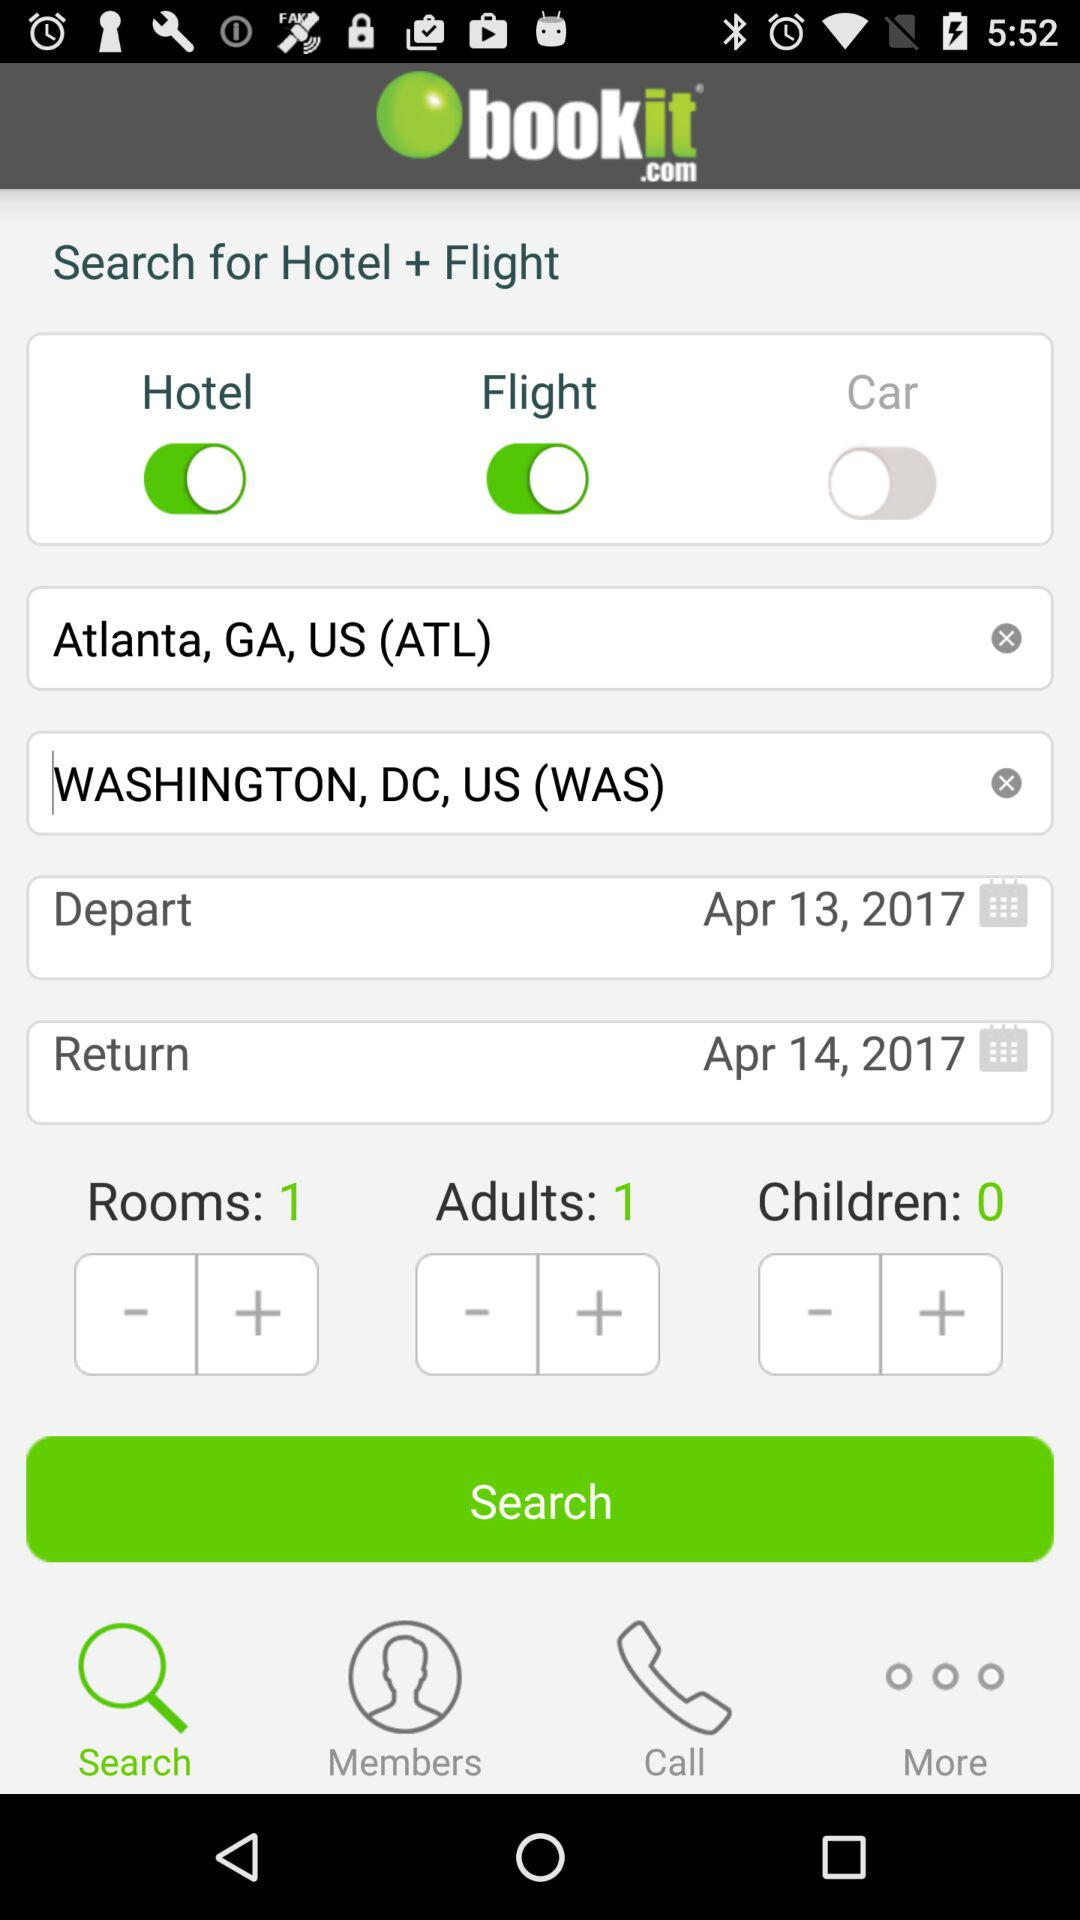What is the name of the application? The name of the application is "bookit.com". 